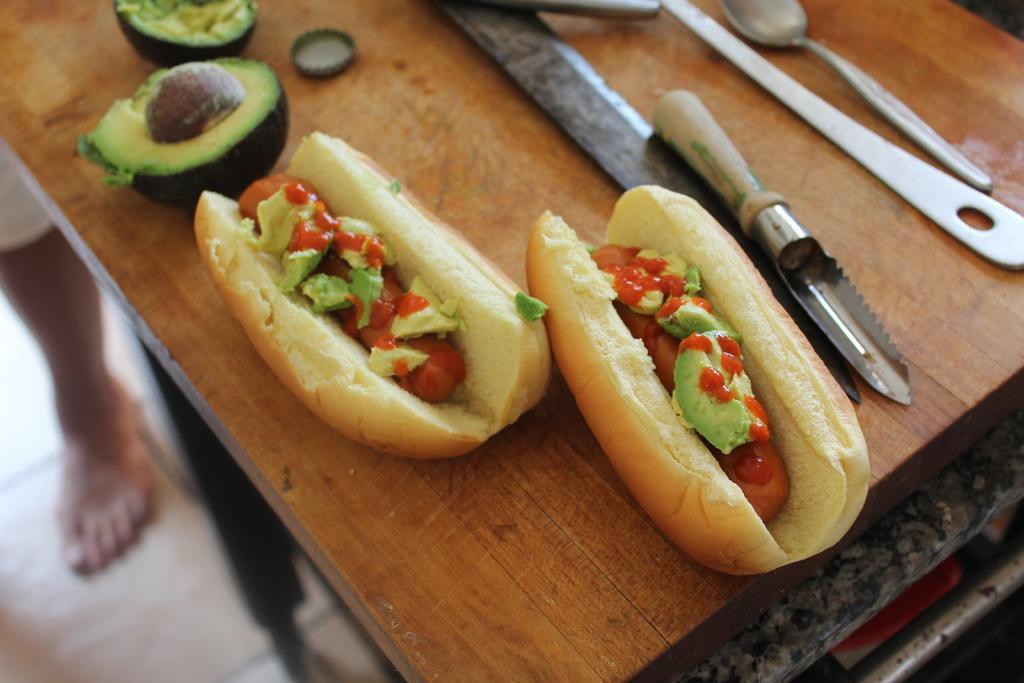Can you describe this image briefly? In this image we can see food items, spoon and other objects on the surface. On the left side of the image there is a person's leg and an object. On the right side of the image there are some objects. 